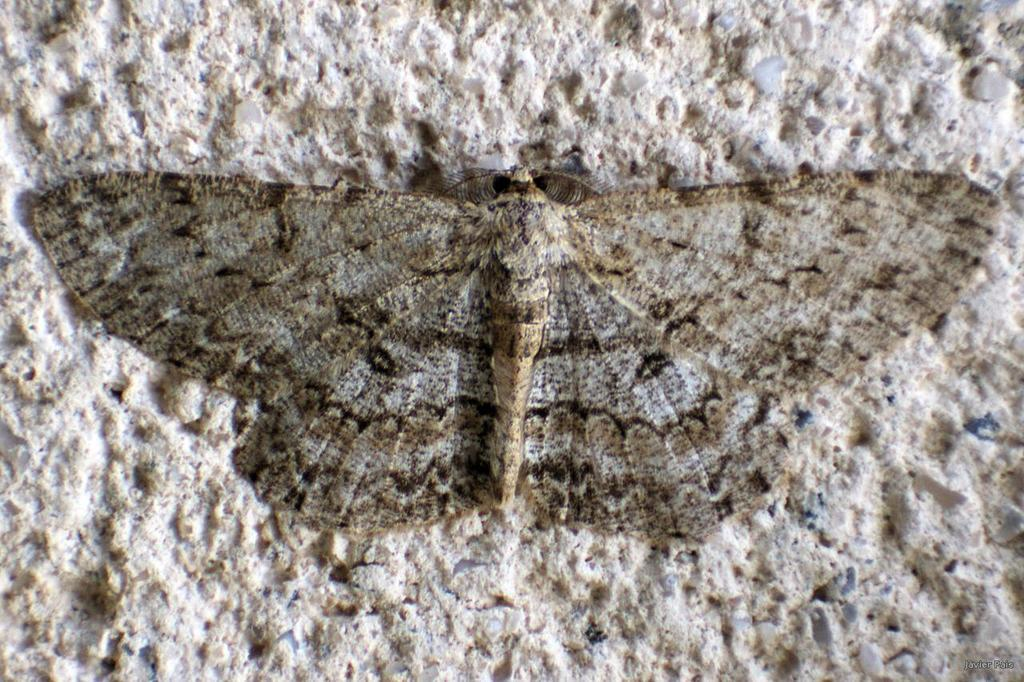What type of creature is present in the image? There is a butterfly in the image. Where is the butterfly located in the image? The butterfly is on the floor. How many women are holding umbrellas in the image? There are no women or umbrellas present in the image; it only features a butterfly on the floor. 